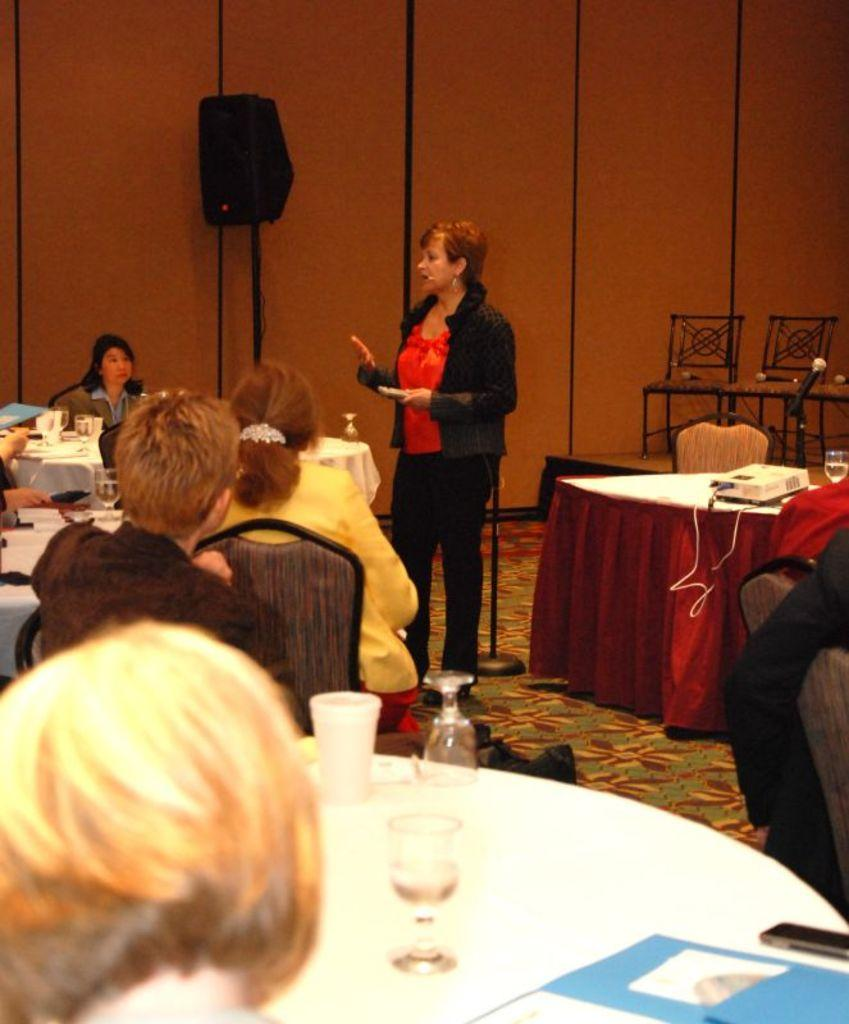Who can be seen in the image? There are people in the image. Can you describe the woman among them? A woman is standing among the people in the image. What can be seen in the background of the image? There is a speaker and chairs in the background of the image. What type of shoe is the boy wearing in the image? There is no boy present in the image, so it is not possible to determine what type of shoe he might be wearing. 